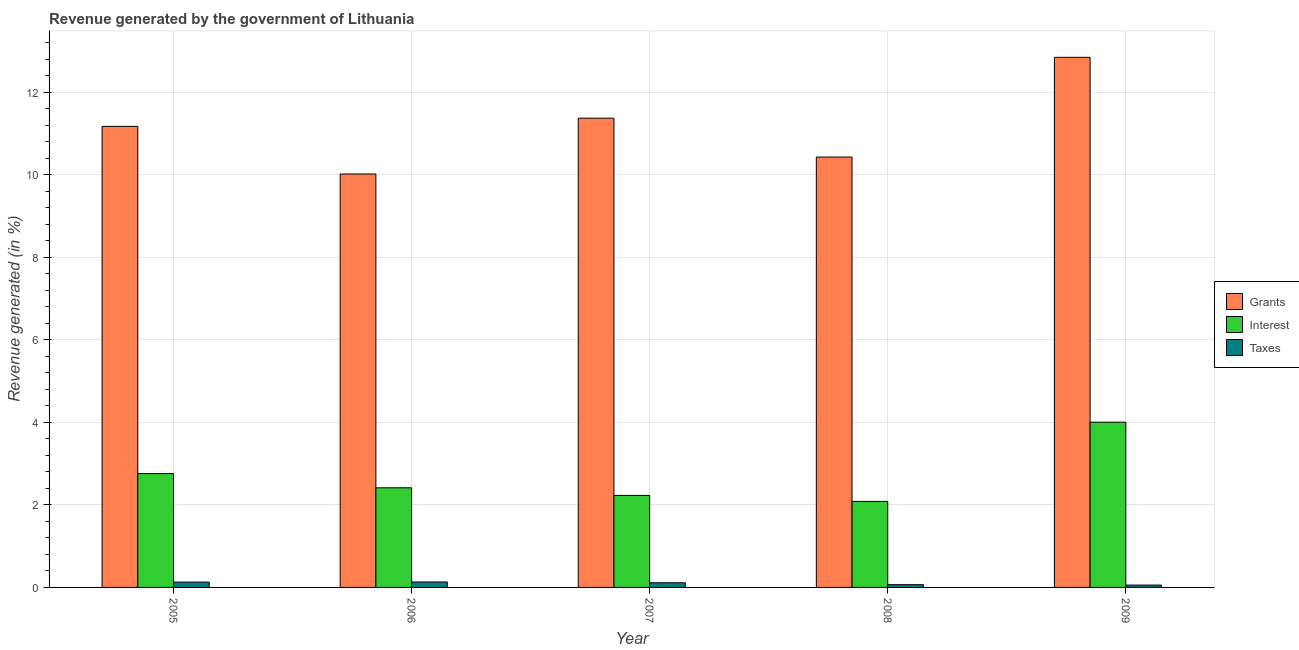How many different coloured bars are there?
Give a very brief answer. 3. How many groups of bars are there?
Ensure brevity in your answer.  5. Are the number of bars per tick equal to the number of legend labels?
Offer a terse response. Yes. How many bars are there on the 4th tick from the left?
Ensure brevity in your answer.  3. What is the percentage of revenue generated by taxes in 2005?
Ensure brevity in your answer.  0.13. Across all years, what is the maximum percentage of revenue generated by interest?
Provide a short and direct response. 4. Across all years, what is the minimum percentage of revenue generated by interest?
Your answer should be very brief. 2.09. In which year was the percentage of revenue generated by taxes maximum?
Offer a terse response. 2006. What is the total percentage of revenue generated by interest in the graph?
Ensure brevity in your answer.  13.49. What is the difference between the percentage of revenue generated by interest in 2006 and that in 2007?
Ensure brevity in your answer.  0.18. What is the difference between the percentage of revenue generated by taxes in 2006 and the percentage of revenue generated by grants in 2009?
Provide a succinct answer. 0.08. What is the average percentage of revenue generated by taxes per year?
Offer a terse response. 0.1. What is the ratio of the percentage of revenue generated by taxes in 2007 to that in 2009?
Your response must be concise. 2. What is the difference between the highest and the second highest percentage of revenue generated by taxes?
Keep it short and to the point. 0. What is the difference between the highest and the lowest percentage of revenue generated by interest?
Your answer should be very brief. 1.92. What does the 2nd bar from the left in 2006 represents?
Give a very brief answer. Interest. What does the 2nd bar from the right in 2009 represents?
Offer a terse response. Interest. Is it the case that in every year, the sum of the percentage of revenue generated by grants and percentage of revenue generated by interest is greater than the percentage of revenue generated by taxes?
Give a very brief answer. Yes. How many bars are there?
Offer a terse response. 15. Does the graph contain any zero values?
Provide a succinct answer. No. Does the graph contain grids?
Make the answer very short. Yes. How many legend labels are there?
Give a very brief answer. 3. How are the legend labels stacked?
Offer a very short reply. Vertical. What is the title of the graph?
Your answer should be very brief. Revenue generated by the government of Lithuania. Does "Errors" appear as one of the legend labels in the graph?
Provide a succinct answer. No. What is the label or title of the Y-axis?
Provide a short and direct response. Revenue generated (in %). What is the Revenue generated (in %) of Grants in 2005?
Ensure brevity in your answer.  11.17. What is the Revenue generated (in %) in Interest in 2005?
Provide a succinct answer. 2.76. What is the Revenue generated (in %) in Taxes in 2005?
Provide a short and direct response. 0.13. What is the Revenue generated (in %) of Grants in 2006?
Offer a terse response. 10.02. What is the Revenue generated (in %) of Interest in 2006?
Provide a short and direct response. 2.41. What is the Revenue generated (in %) in Taxes in 2006?
Your answer should be compact. 0.13. What is the Revenue generated (in %) of Grants in 2007?
Keep it short and to the point. 11.37. What is the Revenue generated (in %) in Interest in 2007?
Ensure brevity in your answer.  2.23. What is the Revenue generated (in %) in Taxes in 2007?
Ensure brevity in your answer.  0.11. What is the Revenue generated (in %) of Grants in 2008?
Your answer should be compact. 10.43. What is the Revenue generated (in %) of Interest in 2008?
Offer a terse response. 2.09. What is the Revenue generated (in %) of Taxes in 2008?
Your answer should be compact. 0.07. What is the Revenue generated (in %) in Grants in 2009?
Provide a succinct answer. 12.85. What is the Revenue generated (in %) of Interest in 2009?
Offer a very short reply. 4. What is the Revenue generated (in %) in Taxes in 2009?
Your answer should be compact. 0.06. Across all years, what is the maximum Revenue generated (in %) of Grants?
Your response must be concise. 12.85. Across all years, what is the maximum Revenue generated (in %) of Interest?
Offer a terse response. 4. Across all years, what is the maximum Revenue generated (in %) of Taxes?
Keep it short and to the point. 0.13. Across all years, what is the minimum Revenue generated (in %) in Grants?
Give a very brief answer. 10.02. Across all years, what is the minimum Revenue generated (in %) in Interest?
Your response must be concise. 2.09. Across all years, what is the minimum Revenue generated (in %) of Taxes?
Provide a succinct answer. 0.06. What is the total Revenue generated (in %) of Grants in the graph?
Give a very brief answer. 55.85. What is the total Revenue generated (in %) in Interest in the graph?
Provide a short and direct response. 13.49. What is the total Revenue generated (in %) in Taxes in the graph?
Provide a short and direct response. 0.5. What is the difference between the Revenue generated (in %) of Grants in 2005 and that in 2006?
Give a very brief answer. 1.15. What is the difference between the Revenue generated (in %) of Interest in 2005 and that in 2006?
Keep it short and to the point. 0.34. What is the difference between the Revenue generated (in %) in Taxes in 2005 and that in 2006?
Your answer should be compact. -0. What is the difference between the Revenue generated (in %) of Grants in 2005 and that in 2007?
Give a very brief answer. -0.2. What is the difference between the Revenue generated (in %) in Interest in 2005 and that in 2007?
Offer a very short reply. 0.53. What is the difference between the Revenue generated (in %) of Taxes in 2005 and that in 2007?
Your response must be concise. 0.02. What is the difference between the Revenue generated (in %) of Grants in 2005 and that in 2008?
Provide a short and direct response. 0.74. What is the difference between the Revenue generated (in %) in Interest in 2005 and that in 2008?
Your answer should be very brief. 0.67. What is the difference between the Revenue generated (in %) of Taxes in 2005 and that in 2008?
Your response must be concise. 0.06. What is the difference between the Revenue generated (in %) in Grants in 2005 and that in 2009?
Your response must be concise. -1.67. What is the difference between the Revenue generated (in %) in Interest in 2005 and that in 2009?
Your answer should be very brief. -1.25. What is the difference between the Revenue generated (in %) of Taxes in 2005 and that in 2009?
Keep it short and to the point. 0.07. What is the difference between the Revenue generated (in %) of Grants in 2006 and that in 2007?
Your answer should be compact. -1.35. What is the difference between the Revenue generated (in %) in Interest in 2006 and that in 2007?
Keep it short and to the point. 0.18. What is the difference between the Revenue generated (in %) in Taxes in 2006 and that in 2007?
Your answer should be very brief. 0.02. What is the difference between the Revenue generated (in %) in Grants in 2006 and that in 2008?
Offer a very short reply. -0.41. What is the difference between the Revenue generated (in %) in Interest in 2006 and that in 2008?
Give a very brief answer. 0.33. What is the difference between the Revenue generated (in %) of Taxes in 2006 and that in 2008?
Your response must be concise. 0.06. What is the difference between the Revenue generated (in %) of Grants in 2006 and that in 2009?
Offer a terse response. -2.83. What is the difference between the Revenue generated (in %) of Interest in 2006 and that in 2009?
Provide a succinct answer. -1.59. What is the difference between the Revenue generated (in %) of Taxes in 2006 and that in 2009?
Offer a terse response. 0.08. What is the difference between the Revenue generated (in %) in Grants in 2007 and that in 2008?
Provide a succinct answer. 0.94. What is the difference between the Revenue generated (in %) of Interest in 2007 and that in 2008?
Ensure brevity in your answer.  0.14. What is the difference between the Revenue generated (in %) in Taxes in 2007 and that in 2008?
Provide a succinct answer. 0.05. What is the difference between the Revenue generated (in %) in Grants in 2007 and that in 2009?
Offer a very short reply. -1.47. What is the difference between the Revenue generated (in %) in Interest in 2007 and that in 2009?
Your answer should be compact. -1.77. What is the difference between the Revenue generated (in %) of Taxes in 2007 and that in 2009?
Provide a short and direct response. 0.06. What is the difference between the Revenue generated (in %) of Grants in 2008 and that in 2009?
Your answer should be compact. -2.42. What is the difference between the Revenue generated (in %) in Interest in 2008 and that in 2009?
Provide a short and direct response. -1.92. What is the difference between the Revenue generated (in %) of Taxes in 2008 and that in 2009?
Your answer should be compact. 0.01. What is the difference between the Revenue generated (in %) of Grants in 2005 and the Revenue generated (in %) of Interest in 2006?
Your answer should be compact. 8.76. What is the difference between the Revenue generated (in %) of Grants in 2005 and the Revenue generated (in %) of Taxes in 2006?
Make the answer very short. 11.04. What is the difference between the Revenue generated (in %) of Interest in 2005 and the Revenue generated (in %) of Taxes in 2006?
Offer a terse response. 2.63. What is the difference between the Revenue generated (in %) in Grants in 2005 and the Revenue generated (in %) in Interest in 2007?
Offer a very short reply. 8.94. What is the difference between the Revenue generated (in %) in Grants in 2005 and the Revenue generated (in %) in Taxes in 2007?
Offer a terse response. 11.06. What is the difference between the Revenue generated (in %) of Interest in 2005 and the Revenue generated (in %) of Taxes in 2007?
Give a very brief answer. 2.65. What is the difference between the Revenue generated (in %) in Grants in 2005 and the Revenue generated (in %) in Interest in 2008?
Offer a very short reply. 9.09. What is the difference between the Revenue generated (in %) in Grants in 2005 and the Revenue generated (in %) in Taxes in 2008?
Provide a succinct answer. 11.11. What is the difference between the Revenue generated (in %) of Interest in 2005 and the Revenue generated (in %) of Taxes in 2008?
Your answer should be compact. 2.69. What is the difference between the Revenue generated (in %) of Grants in 2005 and the Revenue generated (in %) of Interest in 2009?
Offer a terse response. 7.17. What is the difference between the Revenue generated (in %) of Grants in 2005 and the Revenue generated (in %) of Taxes in 2009?
Make the answer very short. 11.12. What is the difference between the Revenue generated (in %) in Interest in 2005 and the Revenue generated (in %) in Taxes in 2009?
Your response must be concise. 2.7. What is the difference between the Revenue generated (in %) of Grants in 2006 and the Revenue generated (in %) of Interest in 2007?
Make the answer very short. 7.79. What is the difference between the Revenue generated (in %) of Grants in 2006 and the Revenue generated (in %) of Taxes in 2007?
Offer a terse response. 9.91. What is the difference between the Revenue generated (in %) in Interest in 2006 and the Revenue generated (in %) in Taxes in 2007?
Your answer should be very brief. 2.3. What is the difference between the Revenue generated (in %) in Grants in 2006 and the Revenue generated (in %) in Interest in 2008?
Your response must be concise. 7.93. What is the difference between the Revenue generated (in %) in Grants in 2006 and the Revenue generated (in %) in Taxes in 2008?
Ensure brevity in your answer.  9.95. What is the difference between the Revenue generated (in %) in Interest in 2006 and the Revenue generated (in %) in Taxes in 2008?
Your answer should be very brief. 2.35. What is the difference between the Revenue generated (in %) of Grants in 2006 and the Revenue generated (in %) of Interest in 2009?
Offer a terse response. 6.01. What is the difference between the Revenue generated (in %) in Grants in 2006 and the Revenue generated (in %) in Taxes in 2009?
Your response must be concise. 9.96. What is the difference between the Revenue generated (in %) in Interest in 2006 and the Revenue generated (in %) in Taxes in 2009?
Your answer should be compact. 2.36. What is the difference between the Revenue generated (in %) in Grants in 2007 and the Revenue generated (in %) in Interest in 2008?
Provide a short and direct response. 9.29. What is the difference between the Revenue generated (in %) in Grants in 2007 and the Revenue generated (in %) in Taxes in 2008?
Give a very brief answer. 11.31. What is the difference between the Revenue generated (in %) of Interest in 2007 and the Revenue generated (in %) of Taxes in 2008?
Your response must be concise. 2.16. What is the difference between the Revenue generated (in %) in Grants in 2007 and the Revenue generated (in %) in Interest in 2009?
Keep it short and to the point. 7.37. What is the difference between the Revenue generated (in %) in Grants in 2007 and the Revenue generated (in %) in Taxes in 2009?
Provide a succinct answer. 11.32. What is the difference between the Revenue generated (in %) in Interest in 2007 and the Revenue generated (in %) in Taxes in 2009?
Ensure brevity in your answer.  2.17. What is the difference between the Revenue generated (in %) in Grants in 2008 and the Revenue generated (in %) in Interest in 2009?
Ensure brevity in your answer.  6.43. What is the difference between the Revenue generated (in %) of Grants in 2008 and the Revenue generated (in %) of Taxes in 2009?
Offer a very short reply. 10.37. What is the difference between the Revenue generated (in %) in Interest in 2008 and the Revenue generated (in %) in Taxes in 2009?
Your response must be concise. 2.03. What is the average Revenue generated (in %) in Grants per year?
Provide a short and direct response. 11.17. What is the average Revenue generated (in %) in Interest per year?
Your answer should be compact. 2.7. What is the average Revenue generated (in %) in Taxes per year?
Your answer should be very brief. 0.1. In the year 2005, what is the difference between the Revenue generated (in %) in Grants and Revenue generated (in %) in Interest?
Keep it short and to the point. 8.41. In the year 2005, what is the difference between the Revenue generated (in %) in Grants and Revenue generated (in %) in Taxes?
Provide a short and direct response. 11.05. In the year 2005, what is the difference between the Revenue generated (in %) of Interest and Revenue generated (in %) of Taxes?
Provide a short and direct response. 2.63. In the year 2006, what is the difference between the Revenue generated (in %) of Grants and Revenue generated (in %) of Interest?
Your response must be concise. 7.61. In the year 2006, what is the difference between the Revenue generated (in %) of Grants and Revenue generated (in %) of Taxes?
Your response must be concise. 9.89. In the year 2006, what is the difference between the Revenue generated (in %) of Interest and Revenue generated (in %) of Taxes?
Offer a very short reply. 2.28. In the year 2007, what is the difference between the Revenue generated (in %) in Grants and Revenue generated (in %) in Interest?
Your response must be concise. 9.14. In the year 2007, what is the difference between the Revenue generated (in %) of Grants and Revenue generated (in %) of Taxes?
Make the answer very short. 11.26. In the year 2007, what is the difference between the Revenue generated (in %) in Interest and Revenue generated (in %) in Taxes?
Offer a very short reply. 2.12. In the year 2008, what is the difference between the Revenue generated (in %) in Grants and Revenue generated (in %) in Interest?
Provide a succinct answer. 8.35. In the year 2008, what is the difference between the Revenue generated (in %) of Grants and Revenue generated (in %) of Taxes?
Offer a terse response. 10.36. In the year 2008, what is the difference between the Revenue generated (in %) of Interest and Revenue generated (in %) of Taxes?
Ensure brevity in your answer.  2.02. In the year 2009, what is the difference between the Revenue generated (in %) in Grants and Revenue generated (in %) in Interest?
Make the answer very short. 8.84. In the year 2009, what is the difference between the Revenue generated (in %) of Grants and Revenue generated (in %) of Taxes?
Ensure brevity in your answer.  12.79. In the year 2009, what is the difference between the Revenue generated (in %) in Interest and Revenue generated (in %) in Taxes?
Your response must be concise. 3.95. What is the ratio of the Revenue generated (in %) of Grants in 2005 to that in 2006?
Your answer should be compact. 1.12. What is the ratio of the Revenue generated (in %) in Interest in 2005 to that in 2006?
Your answer should be very brief. 1.14. What is the ratio of the Revenue generated (in %) in Taxes in 2005 to that in 2006?
Your response must be concise. 0.98. What is the ratio of the Revenue generated (in %) of Grants in 2005 to that in 2007?
Offer a very short reply. 0.98. What is the ratio of the Revenue generated (in %) of Interest in 2005 to that in 2007?
Keep it short and to the point. 1.24. What is the ratio of the Revenue generated (in %) in Taxes in 2005 to that in 2007?
Offer a very short reply. 1.14. What is the ratio of the Revenue generated (in %) in Grants in 2005 to that in 2008?
Give a very brief answer. 1.07. What is the ratio of the Revenue generated (in %) in Interest in 2005 to that in 2008?
Provide a succinct answer. 1.32. What is the ratio of the Revenue generated (in %) in Taxes in 2005 to that in 2008?
Offer a terse response. 1.91. What is the ratio of the Revenue generated (in %) of Grants in 2005 to that in 2009?
Ensure brevity in your answer.  0.87. What is the ratio of the Revenue generated (in %) of Interest in 2005 to that in 2009?
Offer a terse response. 0.69. What is the ratio of the Revenue generated (in %) of Taxes in 2005 to that in 2009?
Give a very brief answer. 2.28. What is the ratio of the Revenue generated (in %) in Grants in 2006 to that in 2007?
Offer a terse response. 0.88. What is the ratio of the Revenue generated (in %) of Interest in 2006 to that in 2007?
Your response must be concise. 1.08. What is the ratio of the Revenue generated (in %) in Taxes in 2006 to that in 2007?
Your response must be concise. 1.16. What is the ratio of the Revenue generated (in %) in Grants in 2006 to that in 2008?
Keep it short and to the point. 0.96. What is the ratio of the Revenue generated (in %) in Interest in 2006 to that in 2008?
Your response must be concise. 1.16. What is the ratio of the Revenue generated (in %) in Taxes in 2006 to that in 2008?
Make the answer very short. 1.96. What is the ratio of the Revenue generated (in %) of Grants in 2006 to that in 2009?
Your response must be concise. 0.78. What is the ratio of the Revenue generated (in %) in Interest in 2006 to that in 2009?
Provide a short and direct response. 0.6. What is the ratio of the Revenue generated (in %) in Taxes in 2006 to that in 2009?
Keep it short and to the point. 2.33. What is the ratio of the Revenue generated (in %) of Grants in 2007 to that in 2008?
Offer a very short reply. 1.09. What is the ratio of the Revenue generated (in %) of Interest in 2007 to that in 2008?
Give a very brief answer. 1.07. What is the ratio of the Revenue generated (in %) in Taxes in 2007 to that in 2008?
Keep it short and to the point. 1.68. What is the ratio of the Revenue generated (in %) in Grants in 2007 to that in 2009?
Ensure brevity in your answer.  0.89. What is the ratio of the Revenue generated (in %) of Interest in 2007 to that in 2009?
Keep it short and to the point. 0.56. What is the ratio of the Revenue generated (in %) of Taxes in 2007 to that in 2009?
Your response must be concise. 2. What is the ratio of the Revenue generated (in %) of Grants in 2008 to that in 2009?
Your answer should be very brief. 0.81. What is the ratio of the Revenue generated (in %) of Interest in 2008 to that in 2009?
Make the answer very short. 0.52. What is the ratio of the Revenue generated (in %) of Taxes in 2008 to that in 2009?
Give a very brief answer. 1.19. What is the difference between the highest and the second highest Revenue generated (in %) in Grants?
Provide a short and direct response. 1.47. What is the difference between the highest and the second highest Revenue generated (in %) in Interest?
Offer a terse response. 1.25. What is the difference between the highest and the second highest Revenue generated (in %) in Taxes?
Give a very brief answer. 0. What is the difference between the highest and the lowest Revenue generated (in %) in Grants?
Offer a terse response. 2.83. What is the difference between the highest and the lowest Revenue generated (in %) in Interest?
Your answer should be compact. 1.92. What is the difference between the highest and the lowest Revenue generated (in %) of Taxes?
Keep it short and to the point. 0.08. 